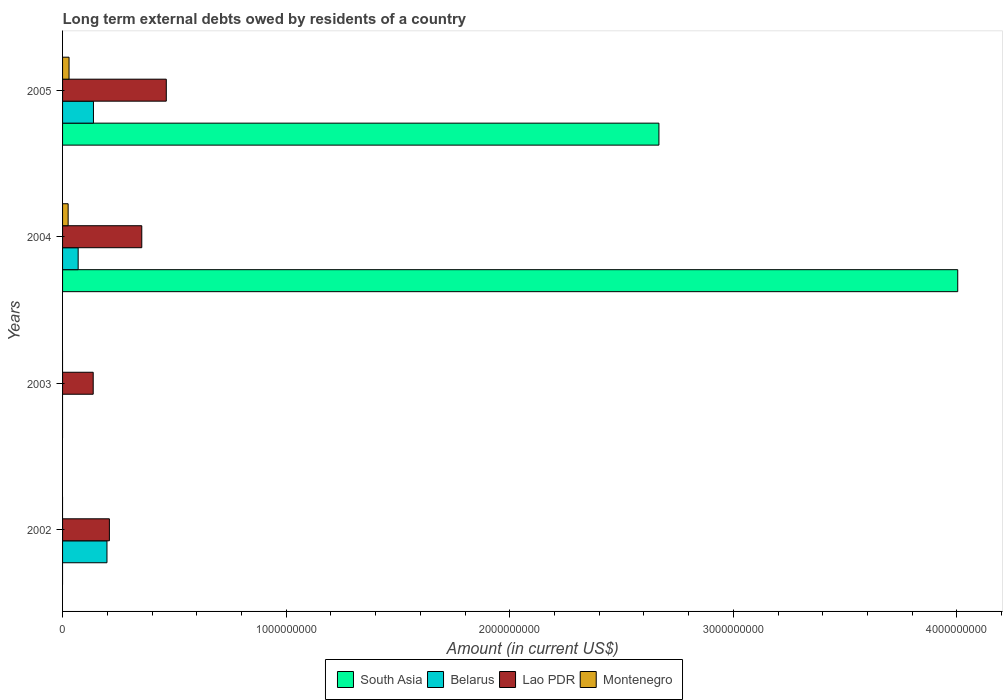How many different coloured bars are there?
Your answer should be compact. 4. How many bars are there on the 1st tick from the top?
Ensure brevity in your answer.  4. What is the label of the 2nd group of bars from the top?
Your answer should be very brief. 2004. In how many cases, is the number of bars for a given year not equal to the number of legend labels?
Provide a short and direct response. 2. Across all years, what is the maximum amount of long-term external debts owed by residents in Lao PDR?
Provide a short and direct response. 4.64e+08. Across all years, what is the minimum amount of long-term external debts owed by residents in Belarus?
Provide a short and direct response. 0. In which year was the amount of long-term external debts owed by residents in Belarus maximum?
Ensure brevity in your answer.  2002. What is the total amount of long-term external debts owed by residents in South Asia in the graph?
Your answer should be very brief. 6.67e+09. What is the difference between the amount of long-term external debts owed by residents in Belarus in 2004 and that in 2005?
Make the answer very short. -6.84e+07. What is the difference between the amount of long-term external debts owed by residents in South Asia in 2005 and the amount of long-term external debts owed by residents in Montenegro in 2002?
Your answer should be compact. 2.67e+09. What is the average amount of long-term external debts owed by residents in Belarus per year?
Offer a very short reply. 1.02e+08. In the year 2002, what is the difference between the amount of long-term external debts owed by residents in Belarus and amount of long-term external debts owed by residents in Lao PDR?
Provide a short and direct response. -1.08e+07. In how many years, is the amount of long-term external debts owed by residents in Belarus greater than 200000000 US$?
Your response must be concise. 0. What is the ratio of the amount of long-term external debts owed by residents in Belarus in 2004 to that in 2005?
Offer a terse response. 0.5. What is the difference between the highest and the second highest amount of long-term external debts owed by residents in Belarus?
Your answer should be very brief. 6.04e+07. What is the difference between the highest and the lowest amount of long-term external debts owed by residents in Lao PDR?
Your response must be concise. 3.27e+08. In how many years, is the amount of long-term external debts owed by residents in Lao PDR greater than the average amount of long-term external debts owed by residents in Lao PDR taken over all years?
Your answer should be very brief. 2. Are the values on the major ticks of X-axis written in scientific E-notation?
Offer a very short reply. No. Does the graph contain any zero values?
Provide a succinct answer. Yes. Where does the legend appear in the graph?
Ensure brevity in your answer.  Bottom center. How many legend labels are there?
Your answer should be very brief. 4. What is the title of the graph?
Your answer should be compact. Long term external debts owed by residents of a country. Does "El Salvador" appear as one of the legend labels in the graph?
Your response must be concise. No. What is the label or title of the X-axis?
Your answer should be very brief. Amount (in current US$). What is the Amount (in current US$) of Belarus in 2002?
Provide a short and direct response. 1.99e+08. What is the Amount (in current US$) of Lao PDR in 2002?
Offer a terse response. 2.09e+08. What is the Amount (in current US$) in Montenegro in 2002?
Offer a terse response. 0. What is the Amount (in current US$) in South Asia in 2003?
Make the answer very short. 0. What is the Amount (in current US$) in Belarus in 2003?
Ensure brevity in your answer.  0. What is the Amount (in current US$) in Lao PDR in 2003?
Ensure brevity in your answer.  1.37e+08. What is the Amount (in current US$) of South Asia in 2004?
Offer a terse response. 4.00e+09. What is the Amount (in current US$) of Belarus in 2004?
Make the answer very short. 6.98e+07. What is the Amount (in current US$) of Lao PDR in 2004?
Provide a short and direct response. 3.54e+08. What is the Amount (in current US$) in Montenegro in 2004?
Offer a terse response. 2.50e+07. What is the Amount (in current US$) of South Asia in 2005?
Provide a short and direct response. 2.67e+09. What is the Amount (in current US$) of Belarus in 2005?
Offer a terse response. 1.38e+08. What is the Amount (in current US$) in Lao PDR in 2005?
Provide a succinct answer. 4.64e+08. What is the Amount (in current US$) of Montenegro in 2005?
Provide a succinct answer. 2.90e+07. Across all years, what is the maximum Amount (in current US$) of South Asia?
Provide a succinct answer. 4.00e+09. Across all years, what is the maximum Amount (in current US$) of Belarus?
Your answer should be compact. 1.99e+08. Across all years, what is the maximum Amount (in current US$) in Lao PDR?
Your answer should be compact. 4.64e+08. Across all years, what is the maximum Amount (in current US$) in Montenegro?
Your answer should be compact. 2.90e+07. Across all years, what is the minimum Amount (in current US$) of South Asia?
Make the answer very short. 0. Across all years, what is the minimum Amount (in current US$) of Lao PDR?
Provide a short and direct response. 1.37e+08. What is the total Amount (in current US$) of South Asia in the graph?
Your answer should be compact. 6.67e+09. What is the total Amount (in current US$) in Belarus in the graph?
Give a very brief answer. 4.06e+08. What is the total Amount (in current US$) of Lao PDR in the graph?
Ensure brevity in your answer.  1.16e+09. What is the total Amount (in current US$) of Montenegro in the graph?
Offer a terse response. 5.40e+07. What is the difference between the Amount (in current US$) in Lao PDR in 2002 and that in 2003?
Offer a terse response. 7.24e+07. What is the difference between the Amount (in current US$) in Belarus in 2002 and that in 2004?
Give a very brief answer. 1.29e+08. What is the difference between the Amount (in current US$) in Lao PDR in 2002 and that in 2004?
Provide a succinct answer. -1.45e+08. What is the difference between the Amount (in current US$) of Belarus in 2002 and that in 2005?
Provide a succinct answer. 6.04e+07. What is the difference between the Amount (in current US$) in Lao PDR in 2002 and that in 2005?
Provide a succinct answer. -2.55e+08. What is the difference between the Amount (in current US$) in Lao PDR in 2003 and that in 2004?
Keep it short and to the point. -2.17e+08. What is the difference between the Amount (in current US$) in Lao PDR in 2003 and that in 2005?
Your answer should be compact. -3.27e+08. What is the difference between the Amount (in current US$) of South Asia in 2004 and that in 2005?
Your response must be concise. 1.34e+09. What is the difference between the Amount (in current US$) of Belarus in 2004 and that in 2005?
Give a very brief answer. -6.84e+07. What is the difference between the Amount (in current US$) in Lao PDR in 2004 and that in 2005?
Your response must be concise. -1.10e+08. What is the difference between the Amount (in current US$) of Montenegro in 2004 and that in 2005?
Make the answer very short. -4.05e+06. What is the difference between the Amount (in current US$) of Belarus in 2002 and the Amount (in current US$) of Lao PDR in 2003?
Keep it short and to the point. 6.15e+07. What is the difference between the Amount (in current US$) in Belarus in 2002 and the Amount (in current US$) in Lao PDR in 2004?
Offer a terse response. -1.56e+08. What is the difference between the Amount (in current US$) in Belarus in 2002 and the Amount (in current US$) in Montenegro in 2004?
Provide a succinct answer. 1.74e+08. What is the difference between the Amount (in current US$) of Lao PDR in 2002 and the Amount (in current US$) of Montenegro in 2004?
Ensure brevity in your answer.  1.84e+08. What is the difference between the Amount (in current US$) of Belarus in 2002 and the Amount (in current US$) of Lao PDR in 2005?
Ensure brevity in your answer.  -2.65e+08. What is the difference between the Amount (in current US$) in Belarus in 2002 and the Amount (in current US$) in Montenegro in 2005?
Make the answer very short. 1.70e+08. What is the difference between the Amount (in current US$) in Lao PDR in 2002 and the Amount (in current US$) in Montenegro in 2005?
Your answer should be very brief. 1.80e+08. What is the difference between the Amount (in current US$) of Lao PDR in 2003 and the Amount (in current US$) of Montenegro in 2004?
Your response must be concise. 1.12e+08. What is the difference between the Amount (in current US$) of Lao PDR in 2003 and the Amount (in current US$) of Montenegro in 2005?
Give a very brief answer. 1.08e+08. What is the difference between the Amount (in current US$) in South Asia in 2004 and the Amount (in current US$) in Belarus in 2005?
Your response must be concise. 3.87e+09. What is the difference between the Amount (in current US$) in South Asia in 2004 and the Amount (in current US$) in Lao PDR in 2005?
Give a very brief answer. 3.54e+09. What is the difference between the Amount (in current US$) in South Asia in 2004 and the Amount (in current US$) in Montenegro in 2005?
Keep it short and to the point. 3.97e+09. What is the difference between the Amount (in current US$) of Belarus in 2004 and the Amount (in current US$) of Lao PDR in 2005?
Keep it short and to the point. -3.94e+08. What is the difference between the Amount (in current US$) of Belarus in 2004 and the Amount (in current US$) of Montenegro in 2005?
Give a very brief answer. 4.07e+07. What is the difference between the Amount (in current US$) of Lao PDR in 2004 and the Amount (in current US$) of Montenegro in 2005?
Your response must be concise. 3.25e+08. What is the average Amount (in current US$) of South Asia per year?
Offer a terse response. 1.67e+09. What is the average Amount (in current US$) of Belarus per year?
Keep it short and to the point. 1.02e+08. What is the average Amount (in current US$) of Lao PDR per year?
Offer a very short reply. 2.91e+08. What is the average Amount (in current US$) in Montenegro per year?
Provide a succinct answer. 1.35e+07. In the year 2002, what is the difference between the Amount (in current US$) in Belarus and Amount (in current US$) in Lao PDR?
Keep it short and to the point. -1.08e+07. In the year 2004, what is the difference between the Amount (in current US$) in South Asia and Amount (in current US$) in Belarus?
Offer a terse response. 3.93e+09. In the year 2004, what is the difference between the Amount (in current US$) in South Asia and Amount (in current US$) in Lao PDR?
Provide a short and direct response. 3.65e+09. In the year 2004, what is the difference between the Amount (in current US$) in South Asia and Amount (in current US$) in Montenegro?
Provide a succinct answer. 3.98e+09. In the year 2004, what is the difference between the Amount (in current US$) in Belarus and Amount (in current US$) in Lao PDR?
Give a very brief answer. -2.85e+08. In the year 2004, what is the difference between the Amount (in current US$) in Belarus and Amount (in current US$) in Montenegro?
Keep it short and to the point. 4.48e+07. In the year 2004, what is the difference between the Amount (in current US$) in Lao PDR and Amount (in current US$) in Montenegro?
Give a very brief answer. 3.29e+08. In the year 2005, what is the difference between the Amount (in current US$) in South Asia and Amount (in current US$) in Belarus?
Offer a terse response. 2.53e+09. In the year 2005, what is the difference between the Amount (in current US$) in South Asia and Amount (in current US$) in Lao PDR?
Give a very brief answer. 2.20e+09. In the year 2005, what is the difference between the Amount (in current US$) in South Asia and Amount (in current US$) in Montenegro?
Offer a terse response. 2.64e+09. In the year 2005, what is the difference between the Amount (in current US$) in Belarus and Amount (in current US$) in Lao PDR?
Ensure brevity in your answer.  -3.26e+08. In the year 2005, what is the difference between the Amount (in current US$) of Belarus and Amount (in current US$) of Montenegro?
Your answer should be very brief. 1.09e+08. In the year 2005, what is the difference between the Amount (in current US$) in Lao PDR and Amount (in current US$) in Montenegro?
Offer a terse response. 4.35e+08. What is the ratio of the Amount (in current US$) of Lao PDR in 2002 to that in 2003?
Your answer should be compact. 1.53. What is the ratio of the Amount (in current US$) of Belarus in 2002 to that in 2004?
Make the answer very short. 2.85. What is the ratio of the Amount (in current US$) of Lao PDR in 2002 to that in 2004?
Your answer should be compact. 0.59. What is the ratio of the Amount (in current US$) in Belarus in 2002 to that in 2005?
Your response must be concise. 1.44. What is the ratio of the Amount (in current US$) of Lao PDR in 2002 to that in 2005?
Provide a short and direct response. 0.45. What is the ratio of the Amount (in current US$) of Lao PDR in 2003 to that in 2004?
Offer a terse response. 0.39. What is the ratio of the Amount (in current US$) of Lao PDR in 2003 to that in 2005?
Provide a short and direct response. 0.3. What is the ratio of the Amount (in current US$) in South Asia in 2004 to that in 2005?
Keep it short and to the point. 1.5. What is the ratio of the Amount (in current US$) in Belarus in 2004 to that in 2005?
Your answer should be compact. 0.5. What is the ratio of the Amount (in current US$) of Lao PDR in 2004 to that in 2005?
Ensure brevity in your answer.  0.76. What is the ratio of the Amount (in current US$) in Montenegro in 2004 to that in 2005?
Your answer should be very brief. 0.86. What is the difference between the highest and the second highest Amount (in current US$) in Belarus?
Offer a very short reply. 6.04e+07. What is the difference between the highest and the second highest Amount (in current US$) of Lao PDR?
Give a very brief answer. 1.10e+08. What is the difference between the highest and the lowest Amount (in current US$) of South Asia?
Ensure brevity in your answer.  4.00e+09. What is the difference between the highest and the lowest Amount (in current US$) of Belarus?
Ensure brevity in your answer.  1.99e+08. What is the difference between the highest and the lowest Amount (in current US$) of Lao PDR?
Offer a very short reply. 3.27e+08. What is the difference between the highest and the lowest Amount (in current US$) in Montenegro?
Offer a terse response. 2.90e+07. 